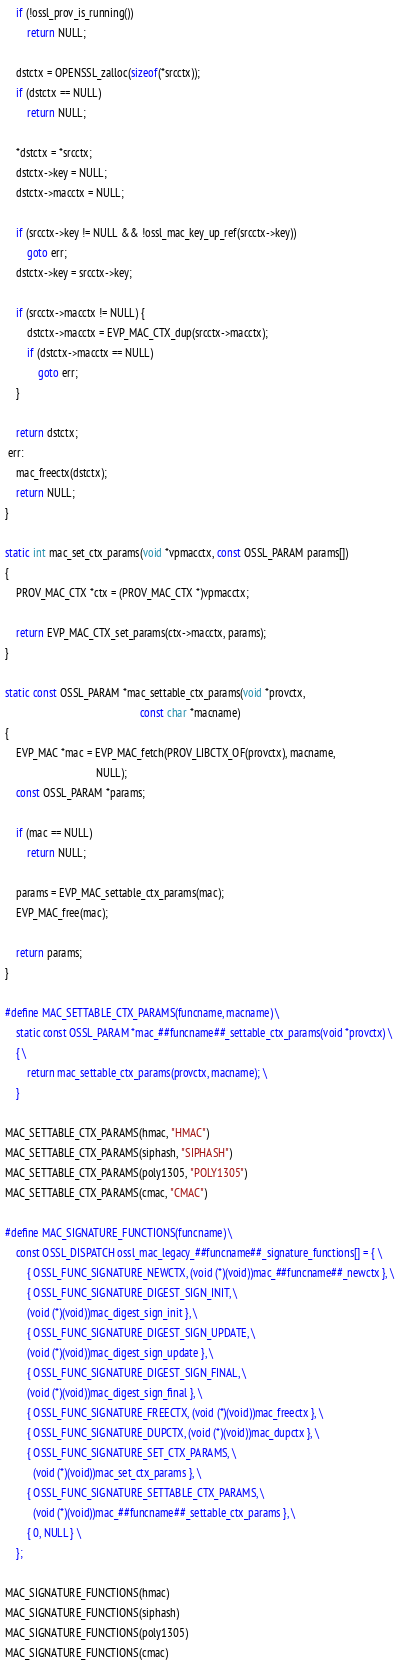Convert code to text. <code><loc_0><loc_0><loc_500><loc_500><_C_>
    if (!ossl_prov_is_running())
        return NULL;

    dstctx = OPENSSL_zalloc(sizeof(*srcctx));
    if (dstctx == NULL)
        return NULL;

    *dstctx = *srcctx;
    dstctx->key = NULL;
    dstctx->macctx = NULL;

    if (srcctx->key != NULL && !ossl_mac_key_up_ref(srcctx->key))
        goto err;
    dstctx->key = srcctx->key;

    if (srcctx->macctx != NULL) {
        dstctx->macctx = EVP_MAC_CTX_dup(srcctx->macctx);
        if (dstctx->macctx == NULL)
            goto err;
    }

    return dstctx;
 err:
    mac_freectx(dstctx);
    return NULL;
}

static int mac_set_ctx_params(void *vpmacctx, const OSSL_PARAM params[])
{
    PROV_MAC_CTX *ctx = (PROV_MAC_CTX *)vpmacctx;

    return EVP_MAC_CTX_set_params(ctx->macctx, params);
}

static const OSSL_PARAM *mac_settable_ctx_params(void *provctx,
                                                 const char *macname)
{
    EVP_MAC *mac = EVP_MAC_fetch(PROV_LIBCTX_OF(provctx), macname,
                                 NULL);
    const OSSL_PARAM *params;

    if (mac == NULL)
        return NULL;

    params = EVP_MAC_settable_ctx_params(mac);
    EVP_MAC_free(mac);

    return params;
}

#define MAC_SETTABLE_CTX_PARAMS(funcname, macname) \
    static const OSSL_PARAM *mac_##funcname##_settable_ctx_params(void *provctx) \
    { \
        return mac_settable_ctx_params(provctx, macname); \
    }

MAC_SETTABLE_CTX_PARAMS(hmac, "HMAC")
MAC_SETTABLE_CTX_PARAMS(siphash, "SIPHASH")
MAC_SETTABLE_CTX_PARAMS(poly1305, "POLY1305")
MAC_SETTABLE_CTX_PARAMS(cmac, "CMAC")

#define MAC_SIGNATURE_FUNCTIONS(funcname) \
    const OSSL_DISPATCH ossl_mac_legacy_##funcname##_signature_functions[] = { \
        { OSSL_FUNC_SIGNATURE_NEWCTX, (void (*)(void))mac_##funcname##_newctx }, \
        { OSSL_FUNC_SIGNATURE_DIGEST_SIGN_INIT, \
        (void (*)(void))mac_digest_sign_init }, \
        { OSSL_FUNC_SIGNATURE_DIGEST_SIGN_UPDATE, \
        (void (*)(void))mac_digest_sign_update }, \
        { OSSL_FUNC_SIGNATURE_DIGEST_SIGN_FINAL, \
        (void (*)(void))mac_digest_sign_final }, \
        { OSSL_FUNC_SIGNATURE_FREECTX, (void (*)(void))mac_freectx }, \
        { OSSL_FUNC_SIGNATURE_DUPCTX, (void (*)(void))mac_dupctx }, \
        { OSSL_FUNC_SIGNATURE_SET_CTX_PARAMS, \
          (void (*)(void))mac_set_ctx_params }, \
        { OSSL_FUNC_SIGNATURE_SETTABLE_CTX_PARAMS, \
          (void (*)(void))mac_##funcname##_settable_ctx_params }, \
        { 0, NULL } \
    };

MAC_SIGNATURE_FUNCTIONS(hmac)
MAC_SIGNATURE_FUNCTIONS(siphash)
MAC_SIGNATURE_FUNCTIONS(poly1305)
MAC_SIGNATURE_FUNCTIONS(cmac)
</code> 